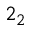<formula> <loc_0><loc_0><loc_500><loc_500>2 _ { 2 }</formula> 